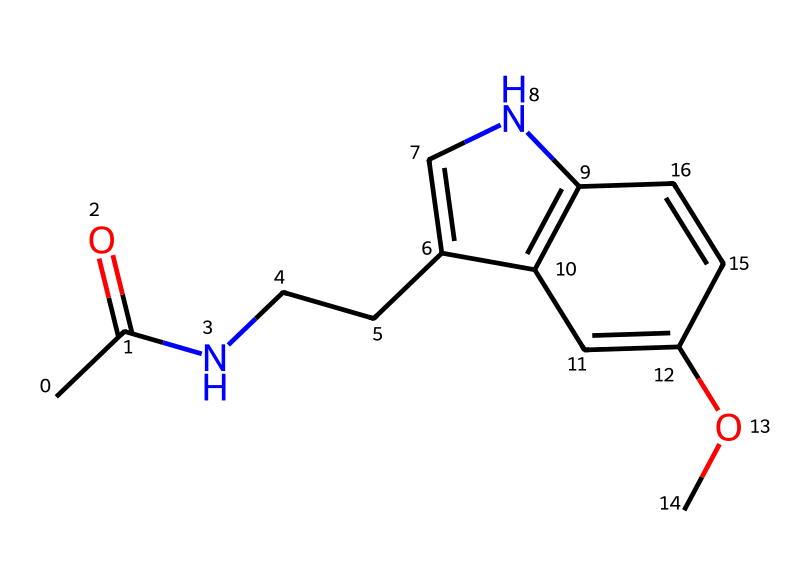How many rings are present in this chemical structure? By examining the SMILES representation, we identify a bicyclic structure where there are two distinct rings present in the molecule.
Answer: two What is the molecular formula of melatonin? The molecular formula can be deduced from counting the atoms represented in the SMILES: there are 13 carbons, 16 hydrogens, 2 nitrogens, and 3 oxygens, forming the molecular formula C13H16N2O3.
Answer: C13H16N2O3 What functional groups are present in this chemical? The structure contains an amide (indicated by -C(=O)N-) and a methoxy group (-OCH3), showing that these two functional groups are indeed part of the molecule.
Answer: amide and methoxy Which bond type is primarily found between the carbon and nitrogen atoms in the amide group? In the amide group, a carbon atom is bonded to a nitrogen atom via a single bond, characteristic of amides that typically involve such bonds.
Answer: single bond Which part of this chemical structure contributes to its sleep-regulating properties? The indole structure derived from the presence of the nitrogen-containing ring system is key to melatonin's function as a sleep-regulating hormone, aligning with its biological activity.
Answer: indole structure 